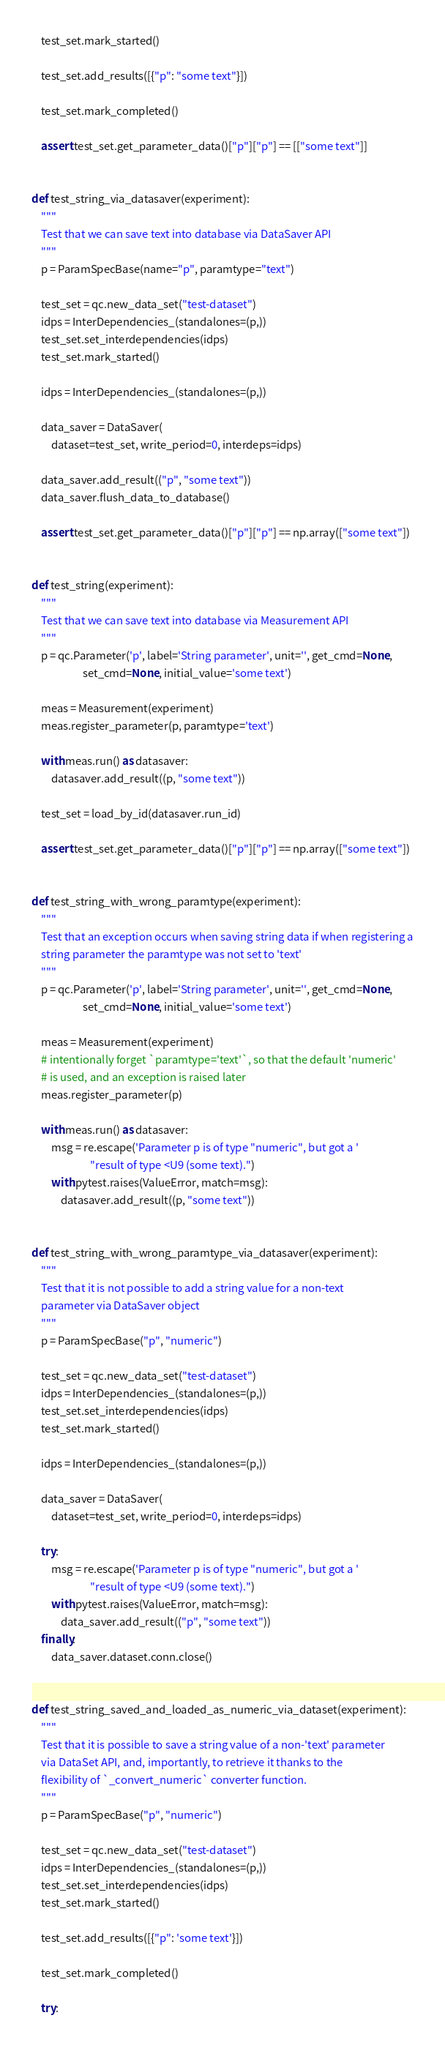Convert code to text. <code><loc_0><loc_0><loc_500><loc_500><_Python_>    test_set.mark_started()

    test_set.add_results([{"p": "some text"}])

    test_set.mark_completed()

    assert test_set.get_parameter_data()["p"]["p"] == [["some text"]]


def test_string_via_datasaver(experiment):
    """
    Test that we can save text into database via DataSaver API
    """
    p = ParamSpecBase(name="p", paramtype="text")

    test_set = qc.new_data_set("test-dataset")
    idps = InterDependencies_(standalones=(p,))
    test_set.set_interdependencies(idps)
    test_set.mark_started()

    idps = InterDependencies_(standalones=(p,))

    data_saver = DataSaver(
        dataset=test_set, write_period=0, interdeps=idps)

    data_saver.add_result(("p", "some text"))
    data_saver.flush_data_to_database()

    assert test_set.get_parameter_data()["p"]["p"] == np.array(["some text"])


def test_string(experiment):
    """
    Test that we can save text into database via Measurement API
    """
    p = qc.Parameter('p', label='String parameter', unit='', get_cmd=None,
                     set_cmd=None, initial_value='some text')

    meas = Measurement(experiment)
    meas.register_parameter(p, paramtype='text')

    with meas.run() as datasaver:
        datasaver.add_result((p, "some text"))

    test_set = load_by_id(datasaver.run_id)

    assert test_set.get_parameter_data()["p"]["p"] == np.array(["some text"])


def test_string_with_wrong_paramtype(experiment):
    """
    Test that an exception occurs when saving string data if when registering a
    string parameter the paramtype was not set to 'text'
    """
    p = qc.Parameter('p', label='String parameter', unit='', get_cmd=None,
                     set_cmd=None, initial_value='some text')

    meas = Measurement(experiment)
    # intentionally forget `paramtype='text'`, so that the default 'numeric'
    # is used, and an exception is raised later
    meas.register_parameter(p)

    with meas.run() as datasaver:
        msg = re.escape('Parameter p is of type "numeric", but got a '
                        "result of type <U9 (some text).")
        with pytest.raises(ValueError, match=msg):
            datasaver.add_result((p, "some text"))


def test_string_with_wrong_paramtype_via_datasaver(experiment):
    """
    Test that it is not possible to add a string value for a non-text
    parameter via DataSaver object
    """
    p = ParamSpecBase("p", "numeric")

    test_set = qc.new_data_set("test-dataset")
    idps = InterDependencies_(standalones=(p,))
    test_set.set_interdependencies(idps)
    test_set.mark_started()

    idps = InterDependencies_(standalones=(p,))

    data_saver = DataSaver(
        dataset=test_set, write_period=0, interdeps=idps)

    try:
        msg = re.escape('Parameter p is of type "numeric", but got a '
                        "result of type <U9 (some text).")
        with pytest.raises(ValueError, match=msg):
            data_saver.add_result(("p", "some text"))
    finally:
        data_saver.dataset.conn.close()


def test_string_saved_and_loaded_as_numeric_via_dataset(experiment):
    """
    Test that it is possible to save a string value of a non-'text' parameter
    via DataSet API, and, importantly, to retrieve it thanks to the
    flexibility of `_convert_numeric` converter function.
    """
    p = ParamSpecBase("p", "numeric")

    test_set = qc.new_data_set("test-dataset")
    idps = InterDependencies_(standalones=(p,))
    test_set.set_interdependencies(idps)
    test_set.mark_started()

    test_set.add_results([{"p": 'some text'}])

    test_set.mark_completed()

    try:</code> 